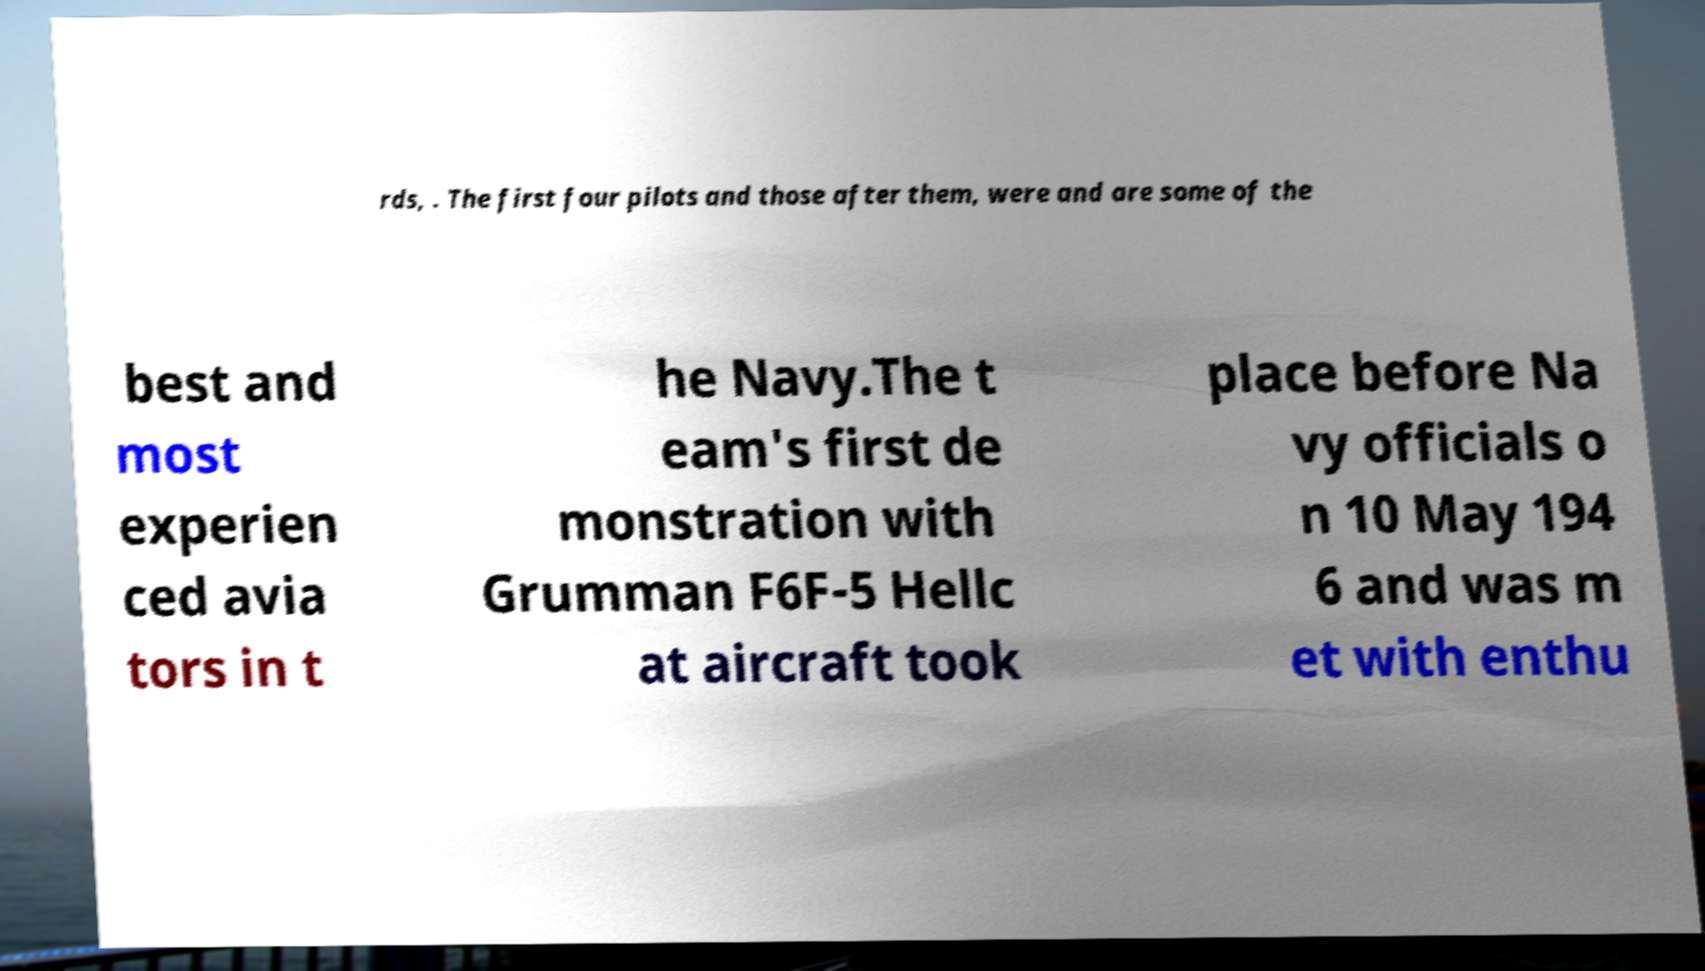Please identify and transcribe the text found in this image. rds, . The first four pilots and those after them, were and are some of the best and most experien ced avia tors in t he Navy.The t eam's first de monstration with Grumman F6F-5 Hellc at aircraft took place before Na vy officials o n 10 May 194 6 and was m et with enthu 